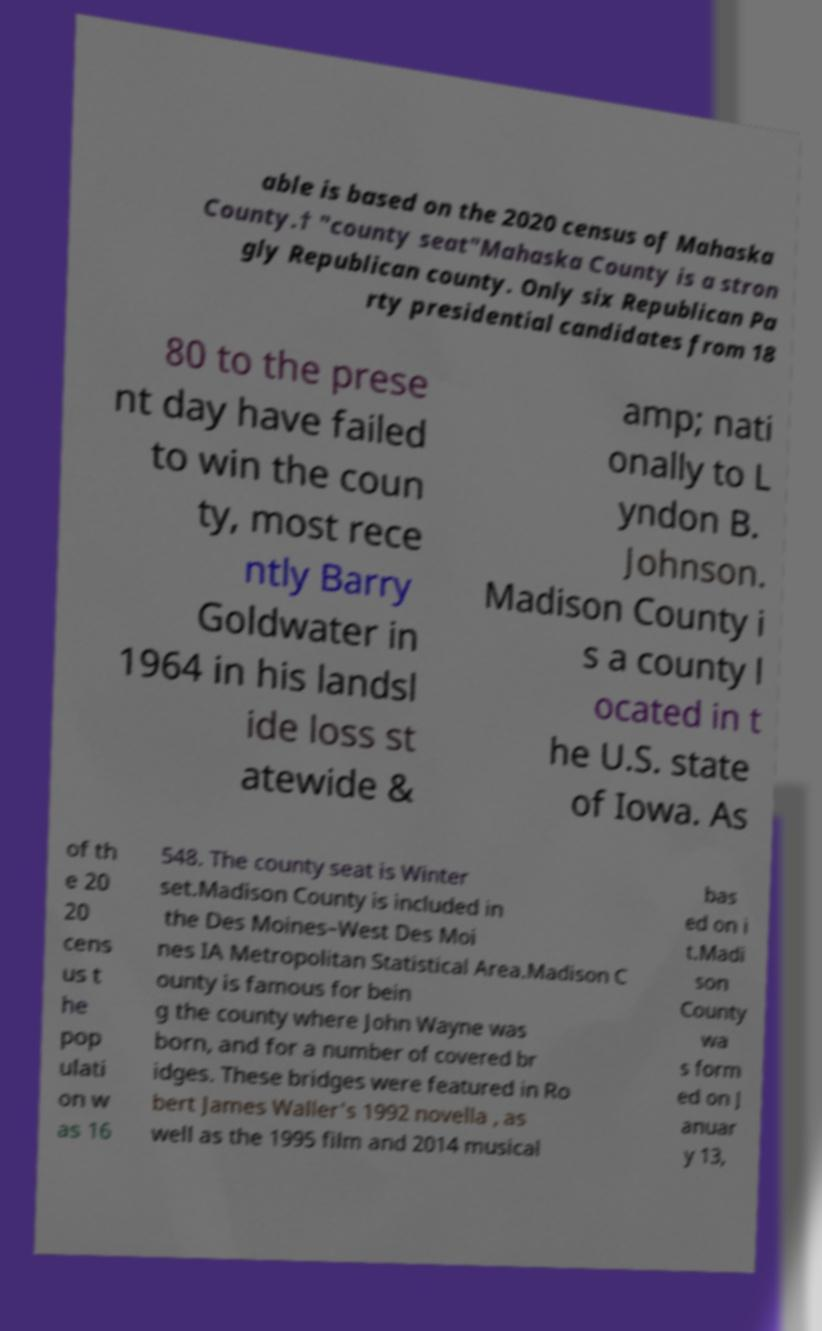Please identify and transcribe the text found in this image. able is based on the 2020 census of Mahaska County.† "county seat"Mahaska County is a stron gly Republican county. Only six Republican Pa rty presidential candidates from 18 80 to the prese nt day have failed to win the coun ty, most rece ntly Barry Goldwater in 1964 in his landsl ide loss st atewide & amp; nati onally to L yndon B. Johnson. Madison County i s a county l ocated in t he U.S. state of Iowa. As of th e 20 20 cens us t he pop ulati on w as 16 548. The county seat is Winter set.Madison County is included in the Des Moines–West Des Moi nes IA Metropolitan Statistical Area.Madison C ounty is famous for bein g the county where John Wayne was born, and for a number of covered br idges. These bridges were featured in Ro bert James Waller's 1992 novella , as well as the 1995 film and 2014 musical bas ed on i t.Madi son County wa s form ed on J anuar y 13, 